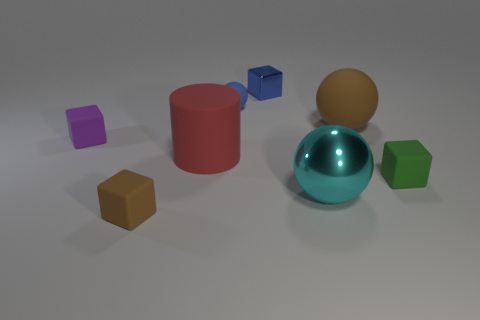What material is the brown object that is the same shape as the small green matte object?
Provide a short and direct response. Rubber. Is there any other thing that has the same material as the tiny green thing?
Your answer should be compact. Yes. What number of balls are tiny blue rubber things or big yellow rubber objects?
Your answer should be very brief. 1. There is a matte thing to the right of the large matte ball; does it have the same size as the block behind the tiny blue rubber object?
Offer a very short reply. Yes. What material is the brown thing in front of the matte ball right of the small blue rubber thing made of?
Keep it short and to the point. Rubber. Are there fewer big metallic objects that are behind the small purple matte object than blue metal cubes?
Your response must be concise. Yes. What is the shape of the small blue object that is the same material as the cyan thing?
Your answer should be compact. Cube. How many other objects are there of the same shape as the purple rubber object?
Make the answer very short. 3. What number of cyan things are either large rubber objects or tiny rubber spheres?
Your response must be concise. 0. Is the purple rubber object the same shape as the tiny green thing?
Make the answer very short. Yes. 